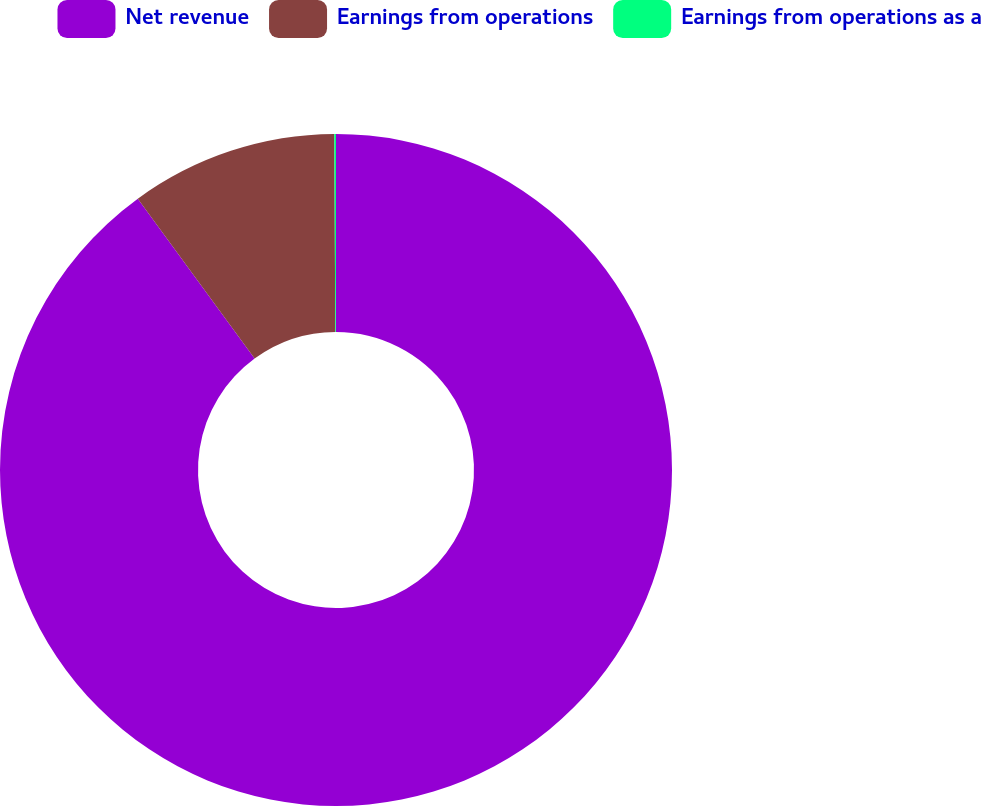Convert chart to OTSL. <chart><loc_0><loc_0><loc_500><loc_500><pie_chart><fcel>Net revenue<fcel>Earnings from operations<fcel>Earnings from operations as a<nl><fcel>89.95%<fcel>9.96%<fcel>0.08%<nl></chart> 